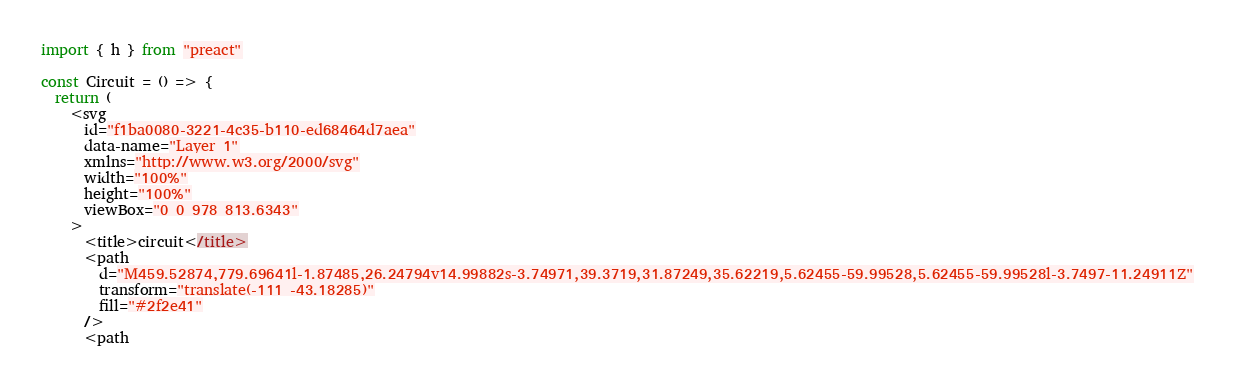<code> <loc_0><loc_0><loc_500><loc_500><_JavaScript_>import { h } from "preact"

const Circuit = () => {
  return (
    <svg
      id="f1ba0080-3221-4c35-b110-ed68464d7aea"
      data-name="Layer 1"
      xmlns="http://www.w3.org/2000/svg"
      width="100%"
      height="100%"
      viewBox="0 0 978 813.6343"
    >
      <title>circuit</title>
      <path
        d="M459.52874,779.69641l-1.87485,26.24794v14.99882s-3.74971,39.3719,31.87249,35.62219,5.62455-59.99528,5.62455-59.99528l-3.7497-11.24911Z"
        transform="translate(-111 -43.18285)"
        fill="#2f2e41"
      />
      <path</code> 